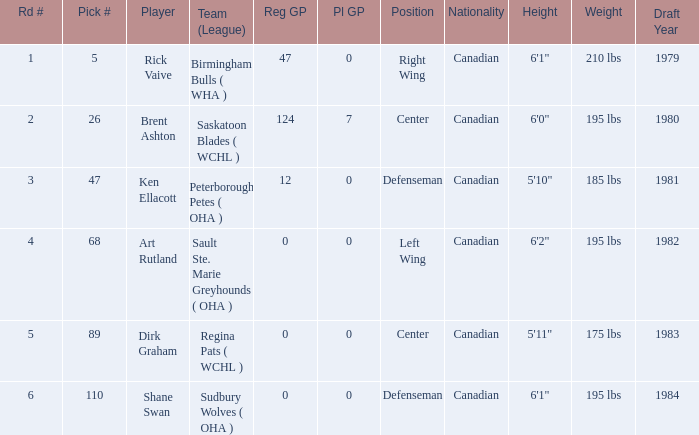How many rounds exist for picks under 5? 0.0. 